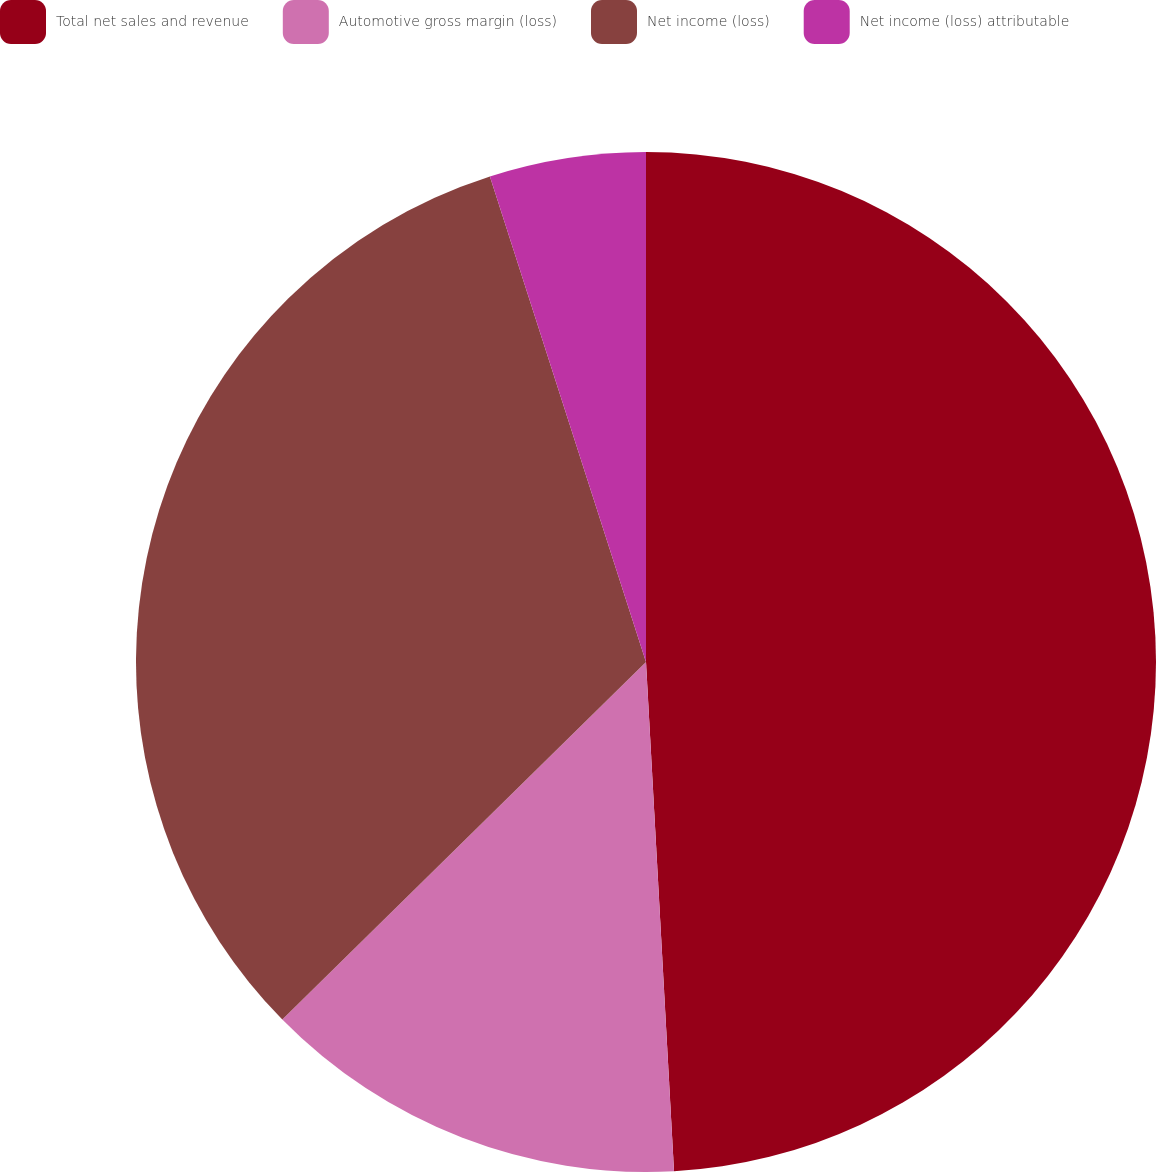<chart> <loc_0><loc_0><loc_500><loc_500><pie_chart><fcel>Total net sales and revenue<fcel>Automotive gross margin (loss)<fcel>Net income (loss)<fcel>Net income (loss) attributable<nl><fcel>49.12%<fcel>13.51%<fcel>32.41%<fcel>4.95%<nl></chart> 